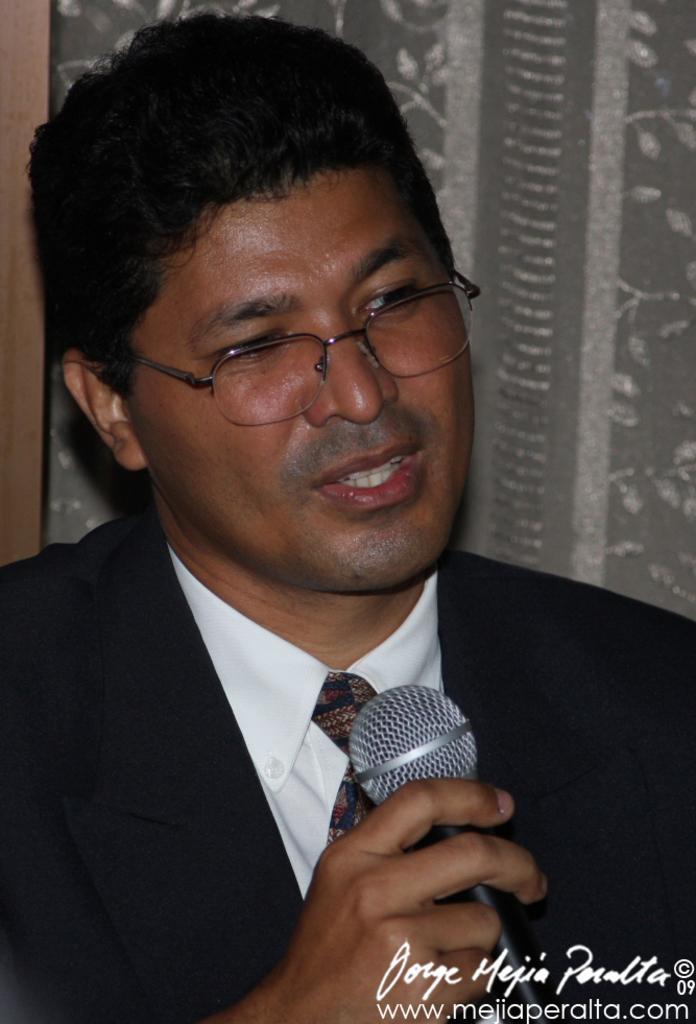Please provide a concise description of this image. He's holding a mic. He's wearing a spectacle and tie. 